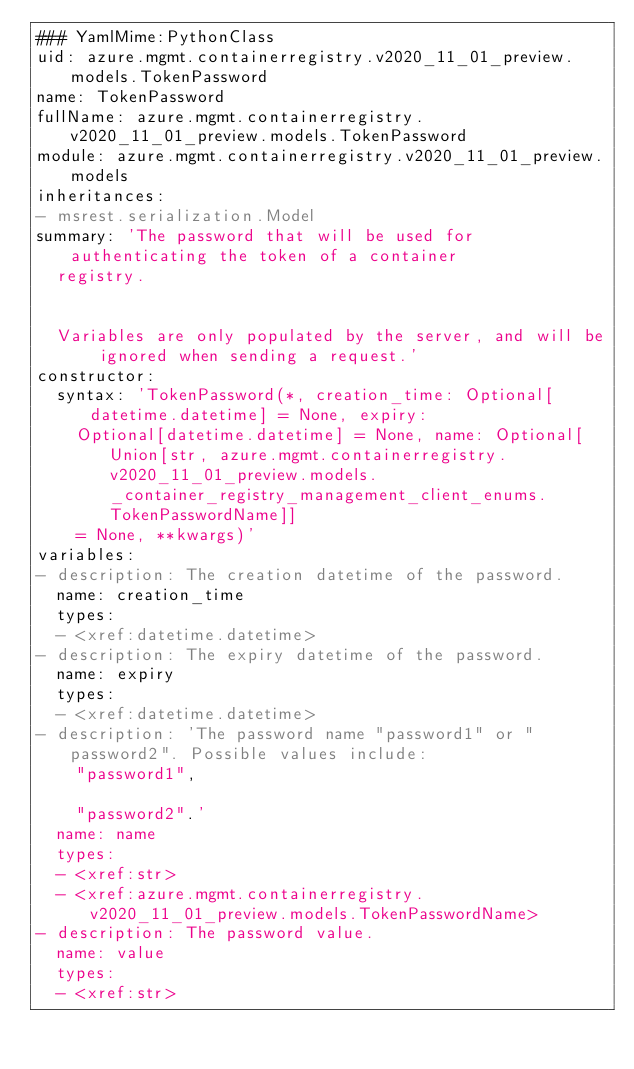Convert code to text. <code><loc_0><loc_0><loc_500><loc_500><_YAML_>### YamlMime:PythonClass
uid: azure.mgmt.containerregistry.v2020_11_01_preview.models.TokenPassword
name: TokenPassword
fullName: azure.mgmt.containerregistry.v2020_11_01_preview.models.TokenPassword
module: azure.mgmt.containerregistry.v2020_11_01_preview.models
inheritances:
- msrest.serialization.Model
summary: 'The password that will be used for authenticating the token of a container
  registry.


  Variables are only populated by the server, and will be ignored when sending a request.'
constructor:
  syntax: 'TokenPassword(*, creation_time: Optional[datetime.datetime] = None, expiry:
    Optional[datetime.datetime] = None, name: Optional[Union[str, azure.mgmt.containerregistry.v2020_11_01_preview.models._container_registry_management_client_enums.TokenPasswordName]]
    = None, **kwargs)'
variables:
- description: The creation datetime of the password.
  name: creation_time
  types:
  - <xref:datetime.datetime>
- description: The expiry datetime of the password.
  name: expiry
  types:
  - <xref:datetime.datetime>
- description: 'The password name "password1" or "password2". Possible values include:
    "password1",

    "password2".'
  name: name
  types:
  - <xref:str>
  - <xref:azure.mgmt.containerregistry.v2020_11_01_preview.models.TokenPasswordName>
- description: The password value.
  name: value
  types:
  - <xref:str>
</code> 